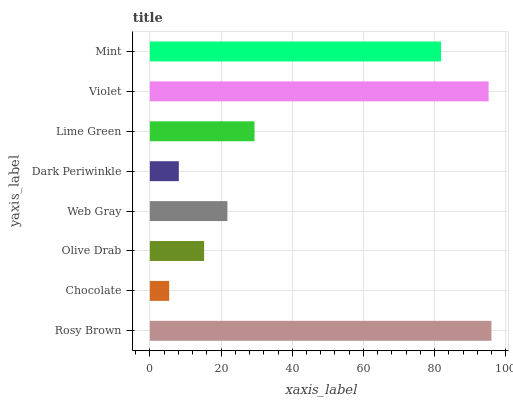Is Chocolate the minimum?
Answer yes or no. Yes. Is Rosy Brown the maximum?
Answer yes or no. Yes. Is Olive Drab the minimum?
Answer yes or no. No. Is Olive Drab the maximum?
Answer yes or no. No. Is Olive Drab greater than Chocolate?
Answer yes or no. Yes. Is Chocolate less than Olive Drab?
Answer yes or no. Yes. Is Chocolate greater than Olive Drab?
Answer yes or no. No. Is Olive Drab less than Chocolate?
Answer yes or no. No. Is Lime Green the high median?
Answer yes or no. Yes. Is Web Gray the low median?
Answer yes or no. Yes. Is Olive Drab the high median?
Answer yes or no. No. Is Olive Drab the low median?
Answer yes or no. No. 